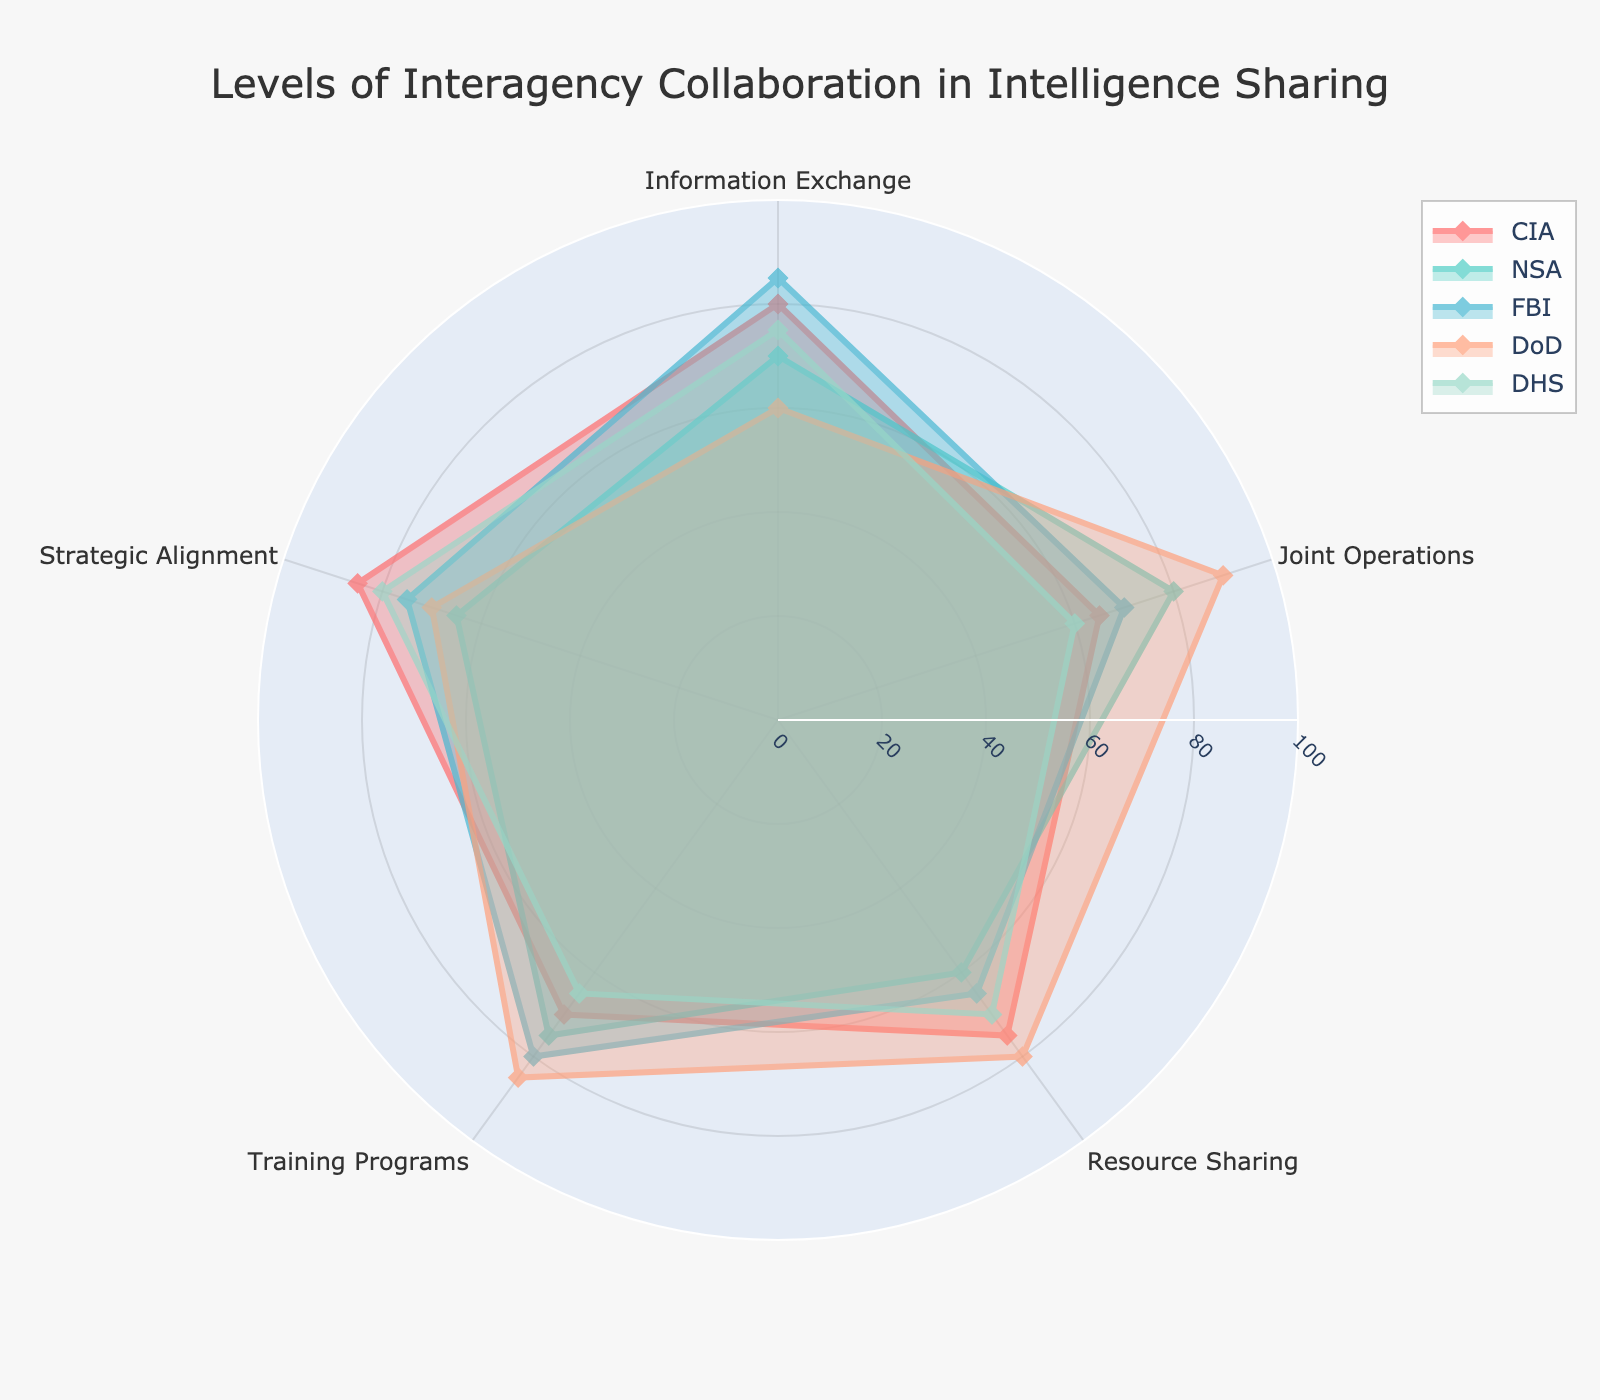what is the title of the figure? The title is displayed at the top of the figure. It reads "Levels of Interagency Collaboration in Intelligence Sharing".
Answer: Levels of Interagency Collaboration in Intelligence Sharing What are the five categories displayed in the radar chart? The categories are the radial axes shown on the radar chart. They include Information Exchange, Joint Operations, Resource Sharing, Training Programs, and Strategic Alignment.
Answer: Information Exchange, Joint Operations, Resource Sharing, Training Programs, Strategic Alignment What is the highest value for the FBI, and in which category does it fall? The highest value for the FBI is observed at the outermost point of the purple line representing the FBI. This value is 85 in the Training Programs category.
Answer: 85 in Training Programs Which agency has the lowest score in Joint Operations, and what is that score? The lowest score in Joint Operations is at the innermost point of a line. The orange line, representing DHS, has the lowest score of 60 in this category.
Answer: DHS with a score of 60 How many agencies have a score of 80 or higher in the Information Exchange category? To determine this, we look at the points where the agency lines intersect the Information Exchange radius. Three agencies (CIA, FBI, and DHS) have scores of 80 or higher.
Answer: Three agencies Which agency has the highest level of Strategic Alignment, and what is its score? The highest level of Strategic Alignment is indicated by the value furthest from the center on the Strategic Alignment axis. The blue line, representing the CIA, has this highest value at 85.
Answer: CIA with a score of 85 What is the average value for the DoD across all categories? Sum the DoD values for all categories: 60 + 90 + 80 + 85 + 70 = 385. Then, divide by the number of categories (5). The average is 385/5 = 77.
Answer: 77 Which category has the highest variability in scores among all agencies? Variability can be inferred by looking at how spread out the values are on the radar chart for each category. "Joint Operations" shows scores ranging from 60 to 90, indicating the highest variability.
Answer: Joint Operations Compare the scores of CIA and DHS in Training Programs and identify the higher score. In the Training Programs category, find the points on the chart where the lines for CIA and DHS intersect the axis. CIA has a score of 70, while DHS has a score of 65. Therefore, the CIA has the higher score in this category.
Answer: CIA with a score of 70 In which category does the NSA score the lowest, and what is the score? We find the lowest point on the green line representing the NSA. This occurs in the Resource Sharing category, where the score is 60.
Answer: Resource Sharing with a score of 60 